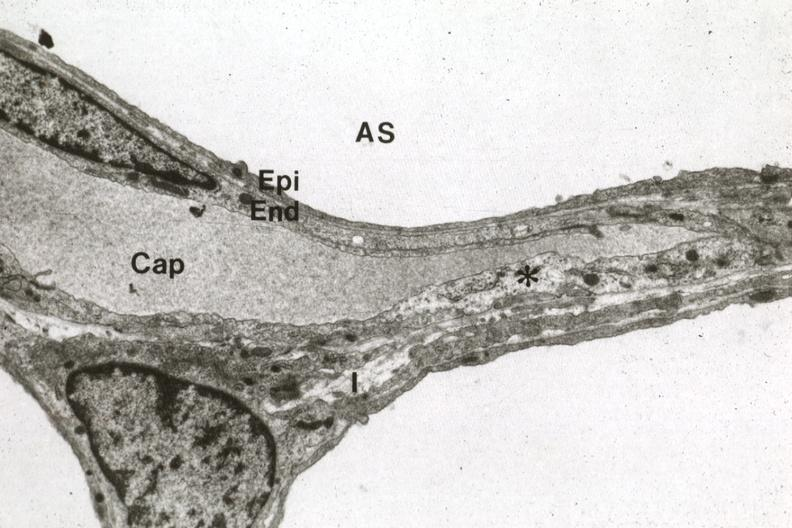does this image show alveolus capillary and interstitial space?
Answer the question using a single word or phrase. Yes 